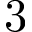<formula> <loc_0><loc_0><loc_500><loc_500>3</formula> 